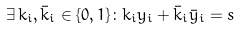Convert formula to latex. <formula><loc_0><loc_0><loc_500><loc_500>\exists \, k _ { i } , \bar { k } _ { i } \in \{ 0 , 1 \} \colon k _ { i } y _ { i } + \bar { k } _ { i } \bar { y } _ { i } = s</formula> 